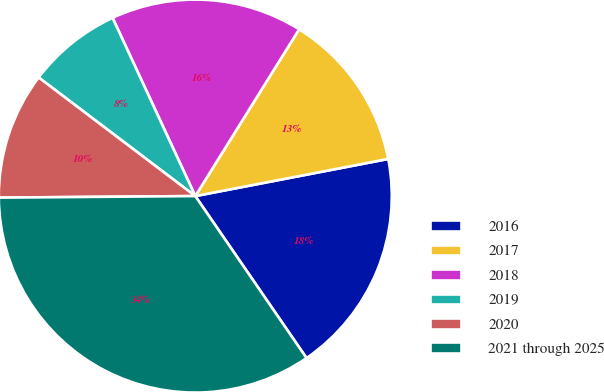Convert chart. <chart><loc_0><loc_0><loc_500><loc_500><pie_chart><fcel>2016<fcel>2017<fcel>2018<fcel>2019<fcel>2020<fcel>2021 through 2025<nl><fcel>18.45%<fcel>13.11%<fcel>15.78%<fcel>7.77%<fcel>10.44%<fcel>34.45%<nl></chart> 